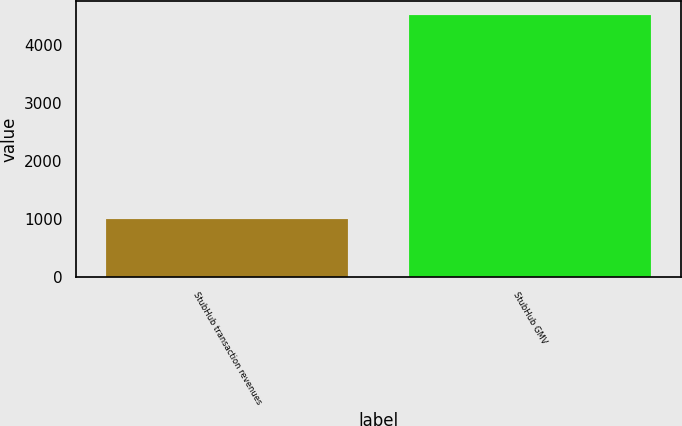Convert chart. <chart><loc_0><loc_0><loc_500><loc_500><bar_chart><fcel>StubHub transaction revenues<fcel>StubHub GMV<nl><fcel>1010<fcel>4520<nl></chart> 